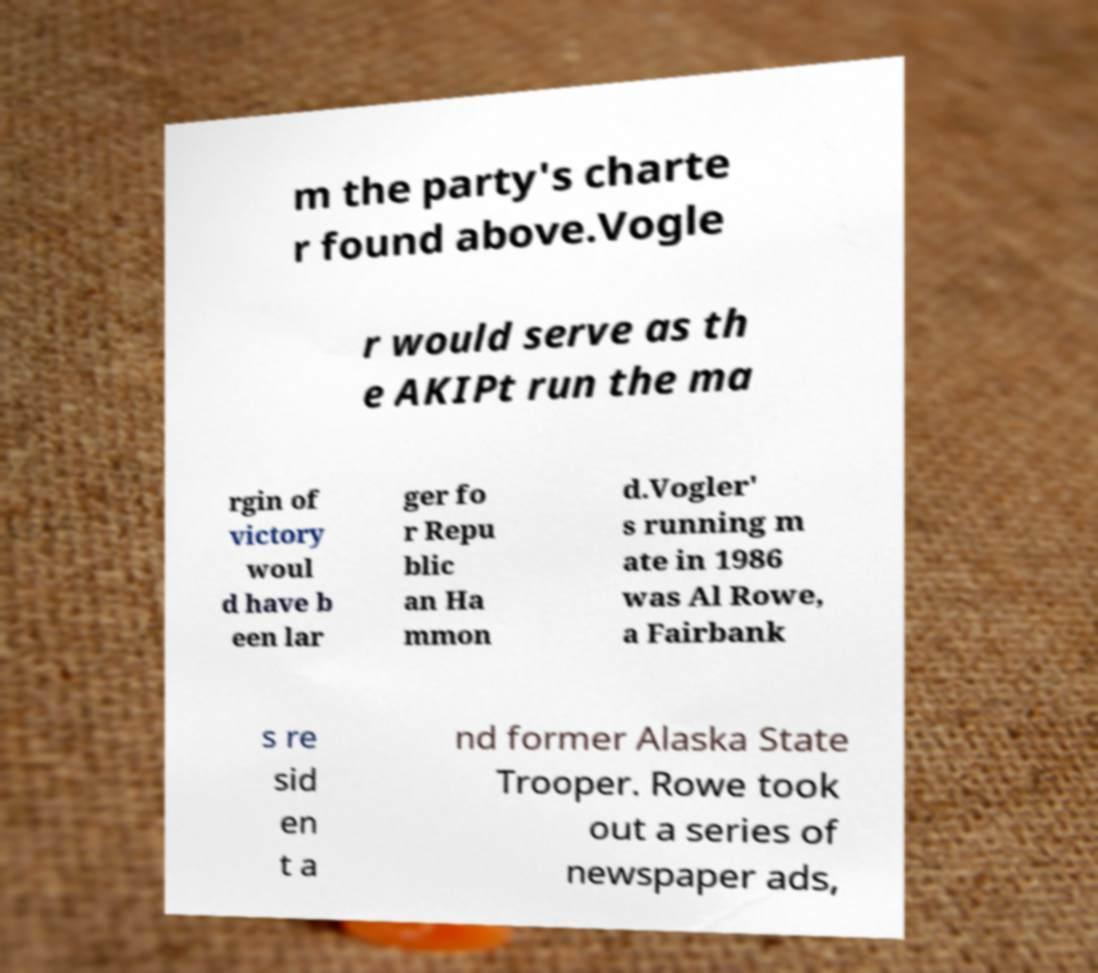Can you read and provide the text displayed in the image?This photo seems to have some interesting text. Can you extract and type it out for me? m the party's charte r found above.Vogle r would serve as th e AKIPt run the ma rgin of victory woul d have b een lar ger fo r Repu blic an Ha mmon d.Vogler' s running m ate in 1986 was Al Rowe, a Fairbank s re sid en t a nd former Alaska State Trooper. Rowe took out a series of newspaper ads, 